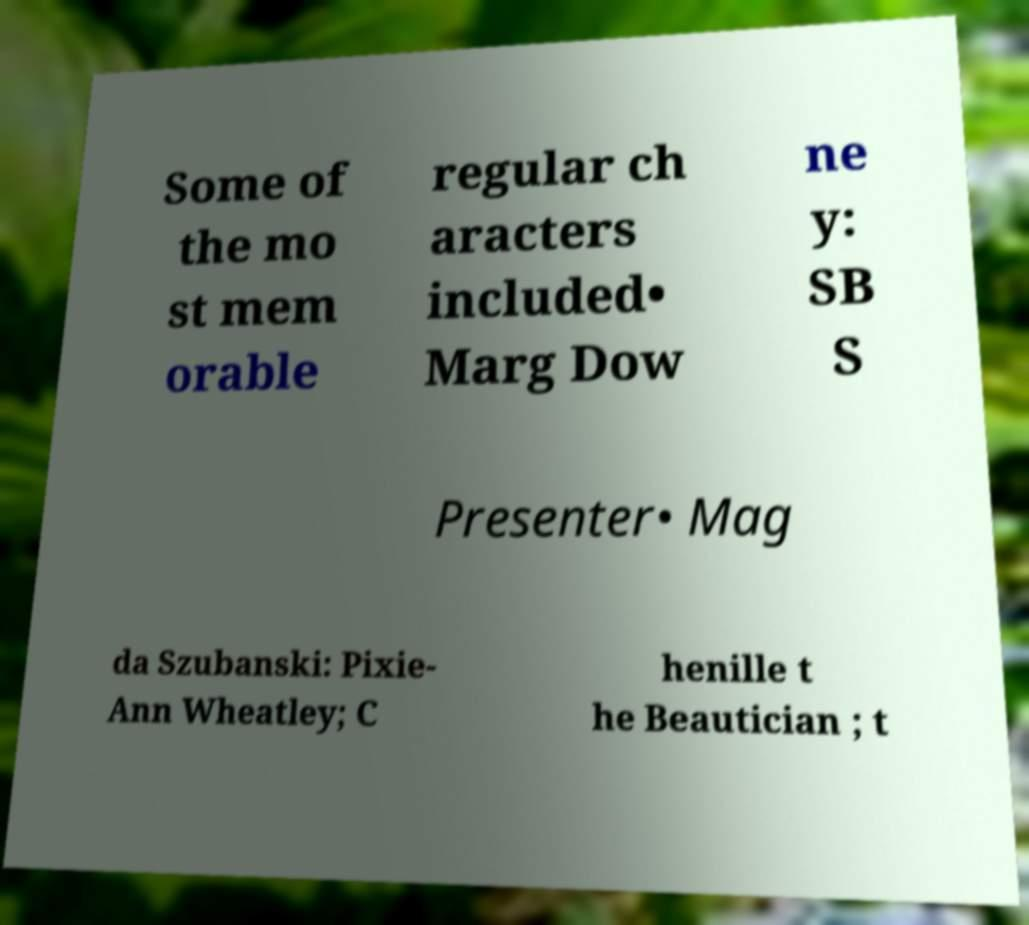Can you read and provide the text displayed in the image?This photo seems to have some interesting text. Can you extract and type it out for me? Some of the mo st mem orable regular ch aracters included• Marg Dow ne y: SB S Presenter• Mag da Szubanski: Pixie- Ann Wheatley; C henille t he Beautician ; t 